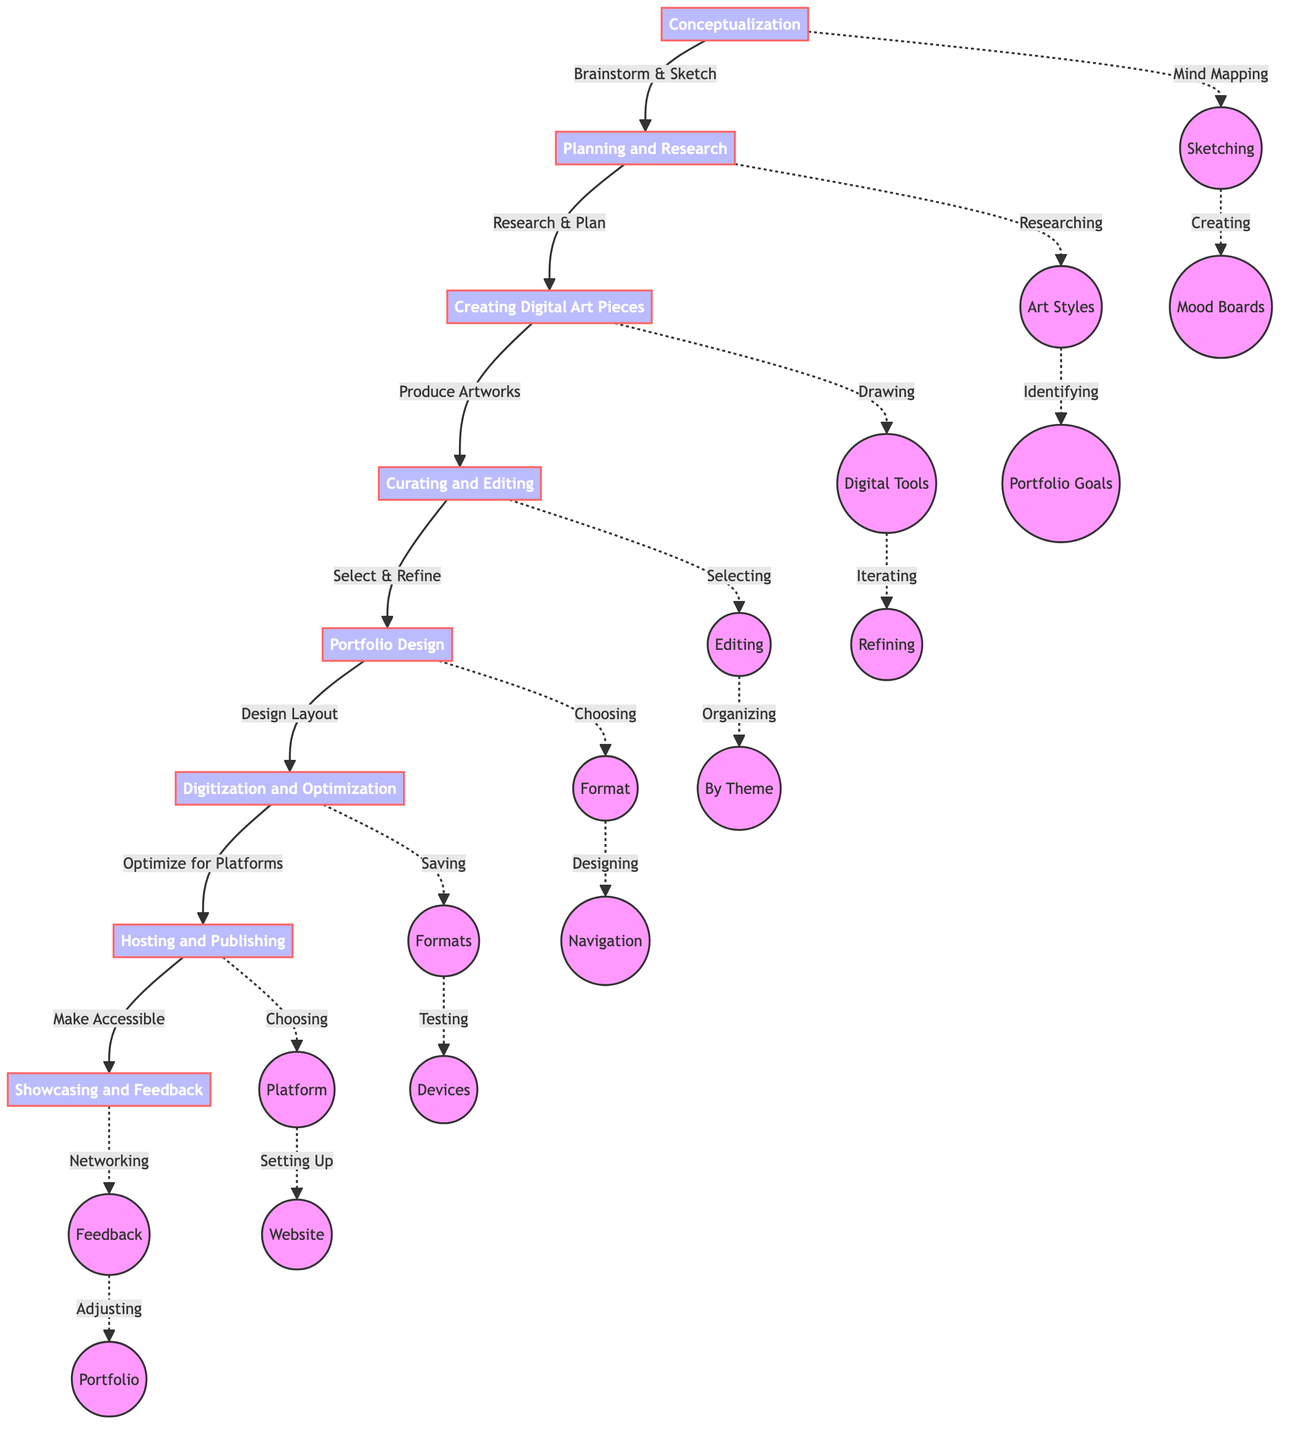What is the first step in the digital art portfolio creation process? The first step is "Conceptualization" as indicated at the top of the flow chart. It represents the beginning of the process before any other steps take place.
Answer: Conceptualization How many main steps are there in the process? Counting each main step in the flowchart from Conceptualization to Showcasing and Feedback, there are eight distinct steps shown.
Answer: 8 Which step comes after "Planning and Research"? The step that follows "Planning and Research" is "Creating Digital Art Pieces," which is connected directly by an arrow indicating the sequence.
Answer: Creating Digital Art Pieces What action follows "Curating and Editing"? The action that comes immediately after "Curating and Editing" is "Portfolio Design," which shows the progression towards designing the portfolio after editing.
Answer: Portfolio Design Which technique is associated with the Conceptualization step? One technique associated with Conceptualization is "Mind Mapping," which is explicitly listed as a detail under that step in the diagram.
Answer: Mind Mapping In what step do you select the best pieces for the portfolio? You select the best pieces for the portfolio in the "Curating and Editing" step, as indicated in the flowchart.
Answer: Curating and Editing What is the last step before showcasing the portfolio? The last step prior to showcasing the portfolio is "Hosting and Publishing," where the portfolio is made accessible to others online.
Answer: Hosting and Publishing What must be ensured during the Digitization and Optimization step? During the Digitization and Optimization step, it must be ensured that the portfolio is "Optimized for various viewing platforms," highlighting the need for compatibility across devices.
Answer: Optimized for various viewing platforms Which platforms are suggested for hosting the portfolio? Suggested platforms for hosting the portfolio include "Behance" and "ArtStation," as mentioned in the Hosting and Publishing step.
Answer: Behance, ArtStation 